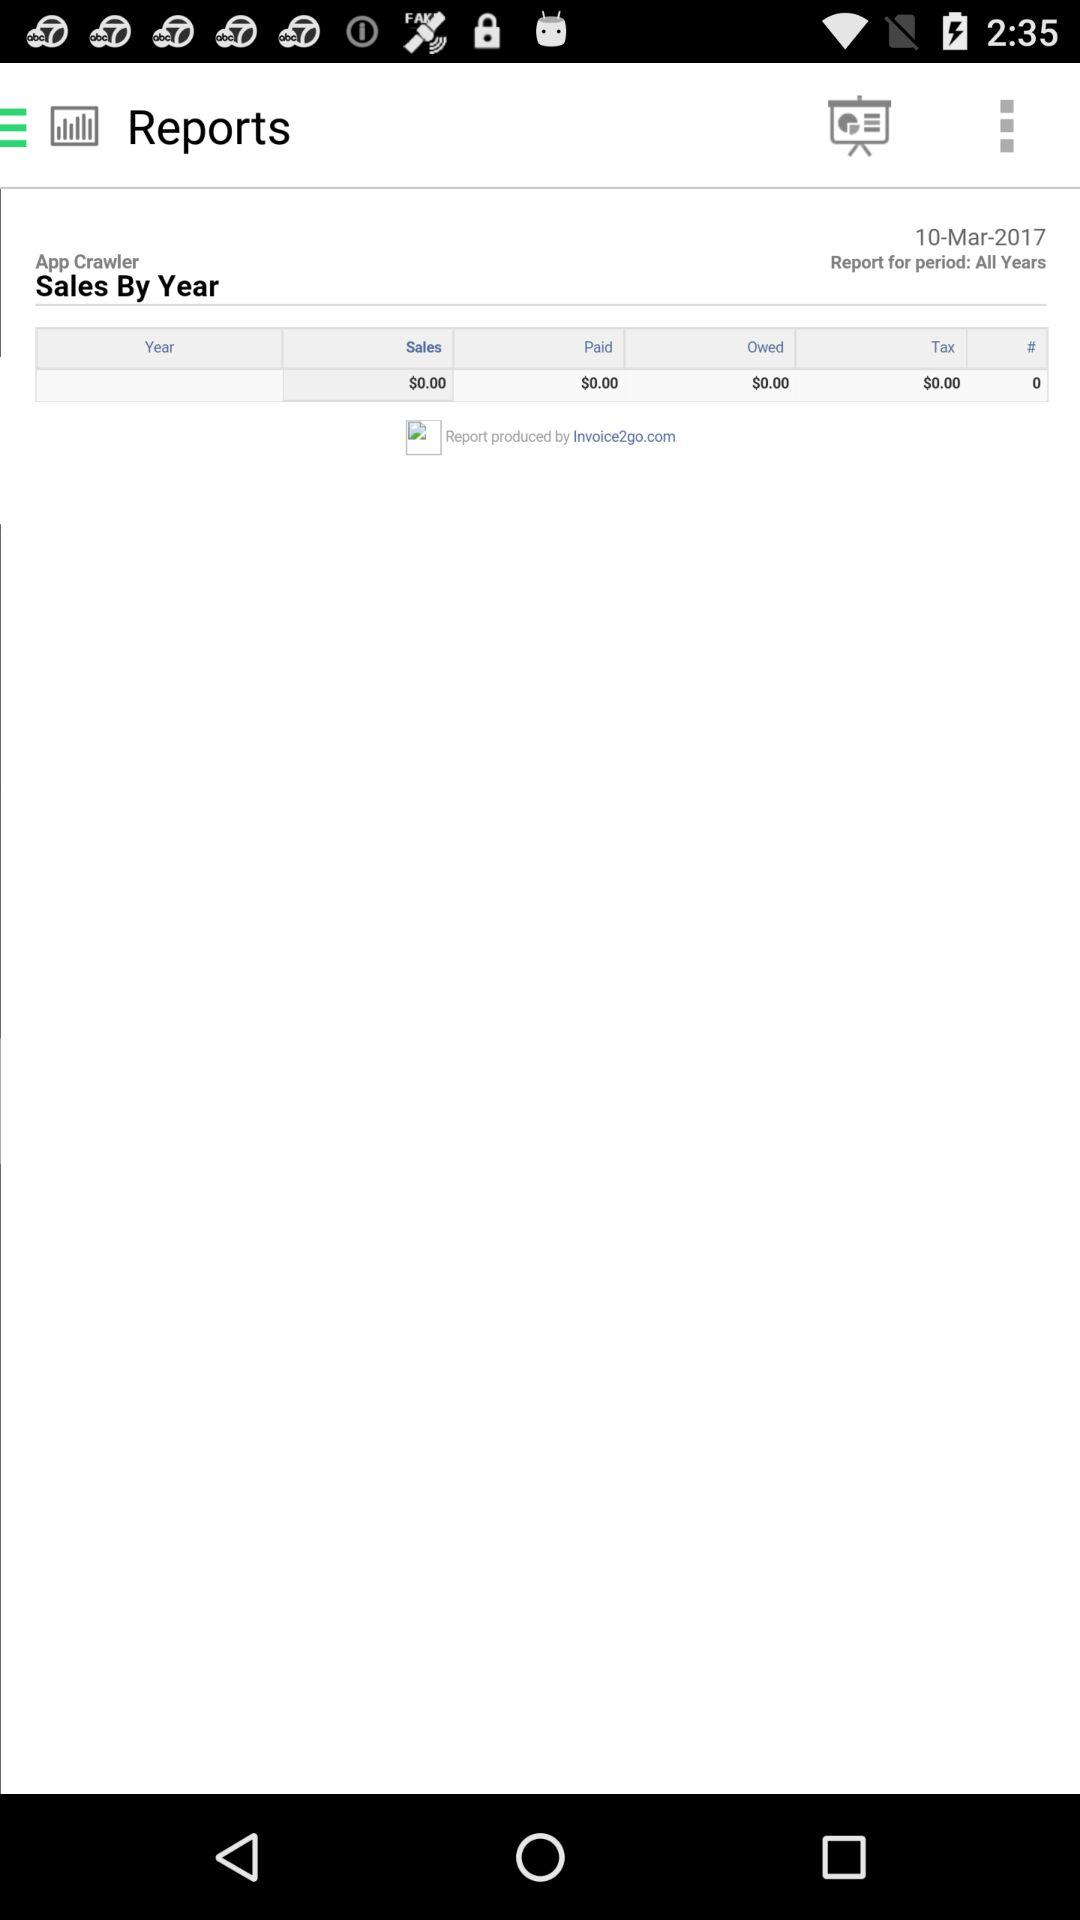What is the username? The username is "App Crawler". 